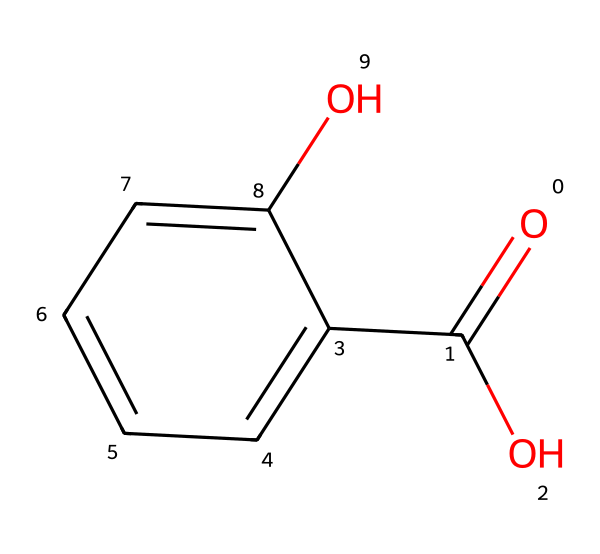what is the molecular formula of salicylic acid? The SMILES representation can be translated into its molecular formula by identifying the atoms present. In this case, there are 7 carbon (C) atoms, 6 hydrogen (H) atoms, and 3 oxygen (O) atoms. Therefore, the molecular formula is C7H6O3.
Answer: C7H6O3 how many hydroxyl groups are present in salicylic acid? By examining the structure in the SMILES, we see that there is a hydroxyl (OH) group attached to the benzene ring and another as part of the carboxylic acid (COOH) functional group. Therefore, there are two hydroxyl groups in salicylic acid.
Answer: 2 what type of functional groups are present in this molecule? The SMILES specifies the presence of a hydroxyl (OH) group and a carboxylic acid (COOH) group. These are the two functional groups identified in salicylic acid.
Answer: hydroxyl and carboxylic acid how many rings are present in the structure of salicylic acid? The structure described in the SMILES indicates a single aromatic ring, as noted by the 'c' and 'C' notation in the representation, which signifies carbon atoms in a ring. Thus, there is one ring in salicylic acid.
Answer: 1 what is the main application of salicylic acid in skincare products? Salicylic acid is primarily used for exfoliation and treating acne due to its ability to penetrate the skin and help unclog pores. This is a key therapeutic property of this compound in skincare.
Answer: acne treatment is salicylic acid considered a phenol? Salicylic acid contains a hydroxyl group directly attached to the aromatic ring, fitting the definition of phenols. Therefore, salicylic acid is classified as a phenol.
Answer: yes 